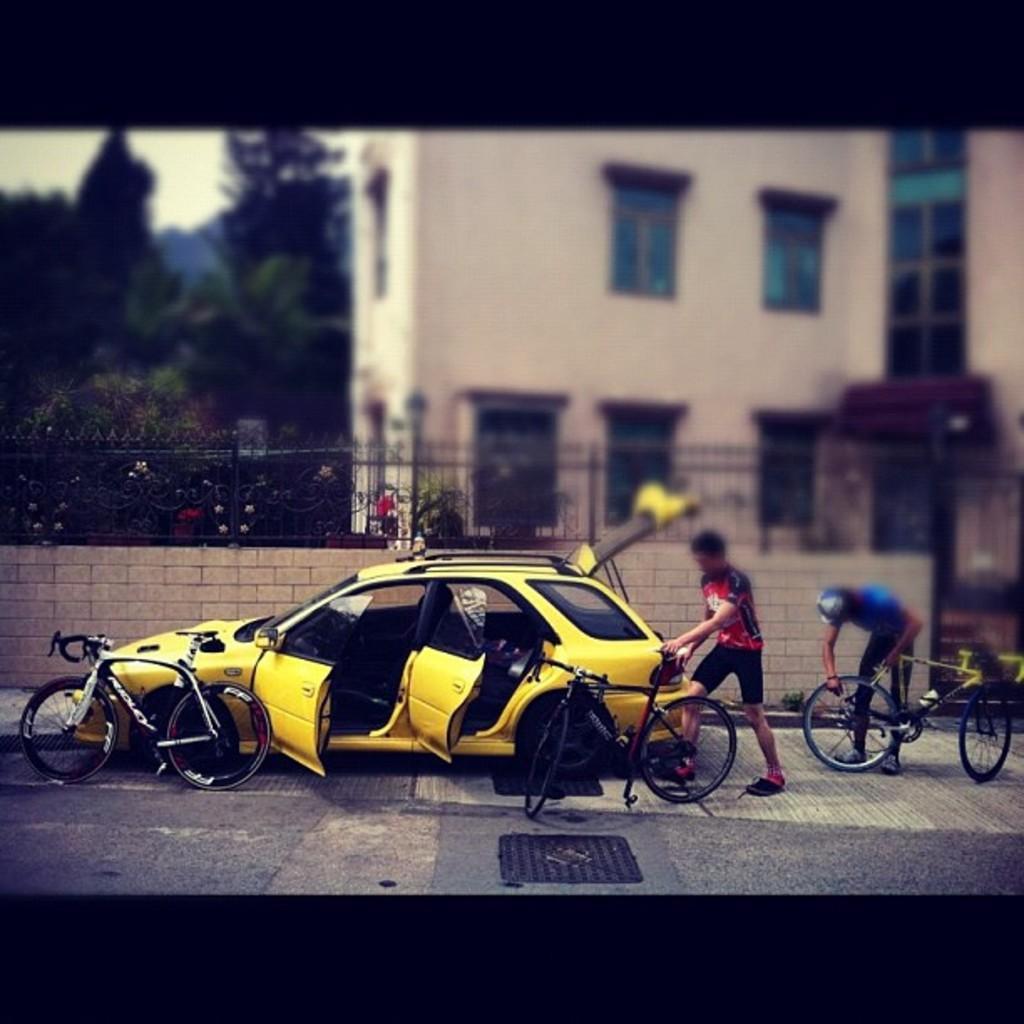How would you summarize this image in a sentence or two? In the image we can see a vehicle, yellow in color. This is a road, bicycles, fence, trees, building, window of the building and tree. We can even see there are two men standing, they are wearing clothes and shoes. This man is wearing a cap. 